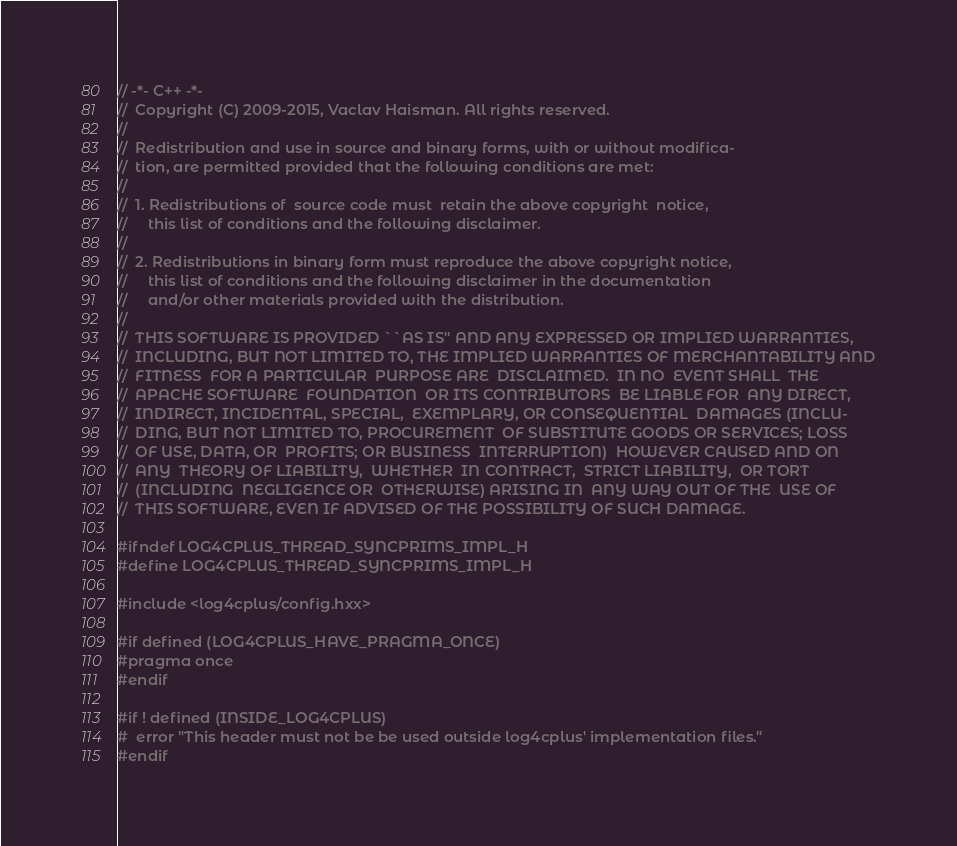<code> <loc_0><loc_0><loc_500><loc_500><_C_>// -*- C++ -*-
//  Copyright (C) 2009-2015, Vaclav Haisman. All rights reserved.
//  
//  Redistribution and use in source and binary forms, with or without modifica-
//  tion, are permitted provided that the following conditions are met:
//  
//  1. Redistributions of  source code must  retain the above copyright  notice,
//     this list of conditions and the following disclaimer.
//  
//  2. Redistributions in binary form must reproduce the above copyright notice,
//     this list of conditions and the following disclaimer in the documentation
//     and/or other materials provided with the distribution.
//  
//  THIS SOFTWARE IS PROVIDED ``AS IS'' AND ANY EXPRESSED OR IMPLIED WARRANTIES,
//  INCLUDING, BUT NOT LIMITED TO, THE IMPLIED WARRANTIES OF MERCHANTABILITY AND
//  FITNESS  FOR A PARTICULAR  PURPOSE ARE  DISCLAIMED.  IN NO  EVENT SHALL  THE
//  APACHE SOFTWARE  FOUNDATION  OR ITS CONTRIBUTORS  BE LIABLE FOR  ANY DIRECT,
//  INDIRECT, INCIDENTAL, SPECIAL,  EXEMPLARY, OR CONSEQUENTIAL  DAMAGES (INCLU-
//  DING, BUT NOT LIMITED TO, PROCUREMENT  OF SUBSTITUTE GOODS OR SERVICES; LOSS
//  OF USE, DATA, OR  PROFITS; OR BUSINESS  INTERRUPTION)  HOWEVER CAUSED AND ON
//  ANY  THEORY OF LIABILITY,  WHETHER  IN CONTRACT,  STRICT LIABILITY,  OR TORT
//  (INCLUDING  NEGLIGENCE OR  OTHERWISE) ARISING IN  ANY WAY OUT OF THE  USE OF
//  THIS SOFTWARE, EVEN IF ADVISED OF THE POSSIBILITY OF SUCH DAMAGE.

#ifndef LOG4CPLUS_THREAD_SYNCPRIMS_IMPL_H
#define LOG4CPLUS_THREAD_SYNCPRIMS_IMPL_H

#include <log4cplus/config.hxx>

#if defined (LOG4CPLUS_HAVE_PRAGMA_ONCE)
#pragma once
#endif

#if ! defined (INSIDE_LOG4CPLUS)
#  error "This header must not be be used outside log4cplus' implementation files."
#endif
</code> 